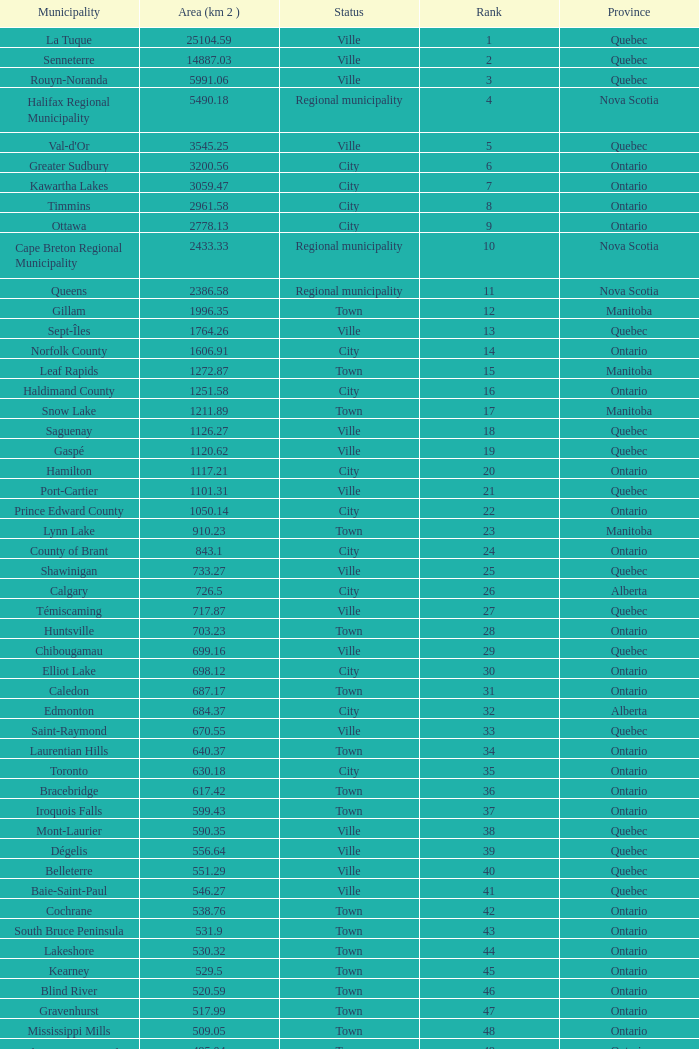What is the listed Status that has the Province of Ontario and Rank of 86? Town. Give me the full table as a dictionary. {'header': ['Municipality', 'Area (km 2 )', 'Status', 'Rank', 'Province'], 'rows': [['La Tuque', '25104.59', 'Ville', '1', 'Quebec'], ['Senneterre', '14887.03', 'Ville', '2', 'Quebec'], ['Rouyn-Noranda', '5991.06', 'Ville', '3', 'Quebec'], ['Halifax Regional Municipality', '5490.18', 'Regional municipality', '4', 'Nova Scotia'], ["Val-d'Or", '3545.25', 'Ville', '5', 'Quebec'], ['Greater Sudbury', '3200.56', 'City', '6', 'Ontario'], ['Kawartha Lakes', '3059.47', 'City', '7', 'Ontario'], ['Timmins', '2961.58', 'City', '8', 'Ontario'], ['Ottawa', '2778.13', 'City', '9', 'Ontario'], ['Cape Breton Regional Municipality', '2433.33', 'Regional municipality', '10', 'Nova Scotia'], ['Queens', '2386.58', 'Regional municipality', '11', 'Nova Scotia'], ['Gillam', '1996.35', 'Town', '12', 'Manitoba'], ['Sept-Îles', '1764.26', 'Ville', '13', 'Quebec'], ['Norfolk County', '1606.91', 'City', '14', 'Ontario'], ['Leaf Rapids', '1272.87', 'Town', '15', 'Manitoba'], ['Haldimand County', '1251.58', 'City', '16', 'Ontario'], ['Snow Lake', '1211.89', 'Town', '17', 'Manitoba'], ['Saguenay', '1126.27', 'Ville', '18', 'Quebec'], ['Gaspé', '1120.62', 'Ville', '19', 'Quebec'], ['Hamilton', '1117.21', 'City', '20', 'Ontario'], ['Port-Cartier', '1101.31', 'Ville', '21', 'Quebec'], ['Prince Edward County', '1050.14', 'City', '22', 'Ontario'], ['Lynn Lake', '910.23', 'Town', '23', 'Manitoba'], ['County of Brant', '843.1', 'City', '24', 'Ontario'], ['Shawinigan', '733.27', 'Ville', '25', 'Quebec'], ['Calgary', '726.5', 'City', '26', 'Alberta'], ['Témiscaming', '717.87', 'Ville', '27', 'Quebec'], ['Huntsville', '703.23', 'Town', '28', 'Ontario'], ['Chibougamau', '699.16', 'Ville', '29', 'Quebec'], ['Elliot Lake', '698.12', 'City', '30', 'Ontario'], ['Caledon', '687.17', 'Town', '31', 'Ontario'], ['Edmonton', '684.37', 'City', '32', 'Alberta'], ['Saint-Raymond', '670.55', 'Ville', '33', 'Quebec'], ['Laurentian Hills', '640.37', 'Town', '34', 'Ontario'], ['Toronto', '630.18', 'City', '35', 'Ontario'], ['Bracebridge', '617.42', 'Town', '36', 'Ontario'], ['Iroquois Falls', '599.43', 'Town', '37', 'Ontario'], ['Mont-Laurier', '590.35', 'Ville', '38', 'Quebec'], ['Dégelis', '556.64', 'Ville', '39', 'Quebec'], ['Belleterre', '551.29', 'Ville', '40', 'Quebec'], ['Baie-Saint-Paul', '546.27', 'Ville', '41', 'Quebec'], ['Cochrane', '538.76', 'Town', '42', 'Ontario'], ['South Bruce Peninsula', '531.9', 'Town', '43', 'Ontario'], ['Lakeshore', '530.32', 'Town', '44', 'Ontario'], ['Kearney', '529.5', 'Town', '45', 'Ontario'], ['Blind River', '520.59', 'Town', '46', 'Ontario'], ['Gravenhurst', '517.99', 'Town', '47', 'Ontario'], ['Mississippi Mills', '509.05', 'Town', '48', 'Ontario'], ['Northeastern Manitoulin and the Islands', '495.04', 'Town', '49', 'Ontario'], ['Quinte West', '493.85', 'City', '50', 'Ontario'], ['Mirabel', '485.51', 'Ville', '51', 'Quebec'], ['Fermont', '470.67', 'Ville', '52', 'Quebec'], ['Winnipeg', '464.01', 'City', '53', 'Manitoba'], ['Greater Napanee', '459.71', 'Town', '54', 'Ontario'], ['La Malbaie', '459.34', 'Ville', '55', 'Quebec'], ['Rivière-Rouge', '454.99', 'Ville', '56', 'Quebec'], ['Québec City', '454.26', 'Ville', '57', 'Quebec'], ['Kingston', '450.39', 'City', '58', 'Ontario'], ['Lévis', '449.32', 'Ville', '59', 'Quebec'], ["St. John's", '446.04', 'City', '60', 'Newfoundland and Labrador'], ['Bécancour', '441', 'Ville', '61', 'Quebec'], ['Percé', '432.39', 'Ville', '62', 'Quebec'], ['Amos', '430.06', 'Ville', '63', 'Quebec'], ['London', '420.57', 'City', '64', 'Ontario'], ['Chandler', '419.5', 'Ville', '65', 'Quebec'], ['Whitehorse', '416.43', 'City', '66', 'Yukon'], ['Gracefield', '386.21', 'Ville', '67', 'Quebec'], ['Baie Verte', '371.07', 'Town', '68', 'Newfoundland and Labrador'], ['Milton', '366.61', 'Town', '69', 'Ontario'], ['Montreal', '365.13', 'Ville', '70', 'Quebec'], ['Saint-Félicien', '363.57', 'Ville', '71', 'Quebec'], ['Abbotsford', '359.36', 'City', '72', 'British Columbia'], ['Sherbrooke', '353.46', 'Ville', '73', 'Quebec'], ['Gatineau', '342.32', 'Ville', '74', 'Quebec'], ['Pohénégamook', '340.33', 'Ville', '75', 'Quebec'], ['Baie-Comeau', '338.88', 'Ville', '76', 'Quebec'], ['Thunder Bay', '328.48', 'City', '77', 'Ontario'], ['Plympton–Wyoming', '318.76', 'Town', '78', 'Ontario'], ['Surrey', '317.19', 'City', '79', 'British Columbia'], ['Prince George', '316', 'City', '80', 'British Columbia'], ['Saint John', '315.49', 'City', '81', 'New Brunswick'], ['North Bay', '314.91', 'City', '82', 'Ontario'], ['Happy Valley-Goose Bay', '305.85', 'Town', '83', 'Newfoundland and Labrador'], ['Minto', '300.37', 'Town', '84', 'Ontario'], ['Kamloops', '297.3', 'City', '85', 'British Columbia'], ['Erin', '296.98', 'Town', '86', 'Ontario'], ['Clarence-Rockland', '296.53', 'City', '87', 'Ontario'], ['Cookshire-Eaton', '295.93', 'Ville', '88', 'Quebec'], ['Dolbeau-Mistassini', '295.67', 'Ville', '89', 'Quebec'], ['Trois-Rivières', '288.92', 'Ville', '90', 'Quebec'], ['Mississauga', '288.53', 'City', '91', 'Ontario'], ['Georgina', '287.72', 'Town', '92', 'Ontario'], ['The Blue Mountains', '286.78', 'Town', '93', 'Ontario'], ['Innisfil', '284.18', 'Town', '94', 'Ontario'], ['Essex', '277.95', 'Town', '95', 'Ontario'], ['Mono', '277.67', 'Town', '96', 'Ontario'], ['Halton Hills', '276.26', 'Town', '97', 'Ontario'], ['New Tecumseth', '274.18', 'Town', '98', 'Ontario'], ['Vaughan', '273.58', 'City', '99', 'Ontario'], ['Brampton', '266.71', 'City', '100', 'Ontario']]} 